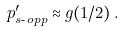Convert formula to latex. <formula><loc_0><loc_0><loc_500><loc_500>p ^ { \prime } _ { s \text {-} o p p } \approx g ( 1 / 2 ) \, .</formula> 